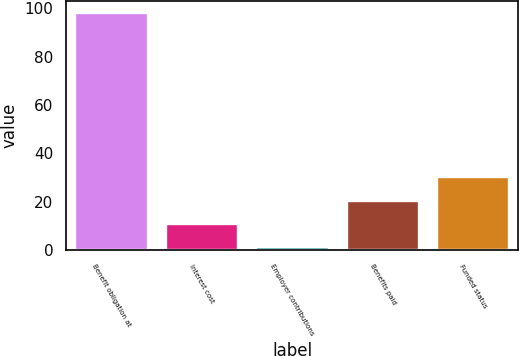<chart> <loc_0><loc_0><loc_500><loc_500><bar_chart><fcel>Benefit obligation at<fcel>Interest cost<fcel>Employer contributions<fcel>Benefits paid<fcel>Funded status<nl><fcel>98<fcel>10.7<fcel>1<fcel>20.4<fcel>30.1<nl></chart> 